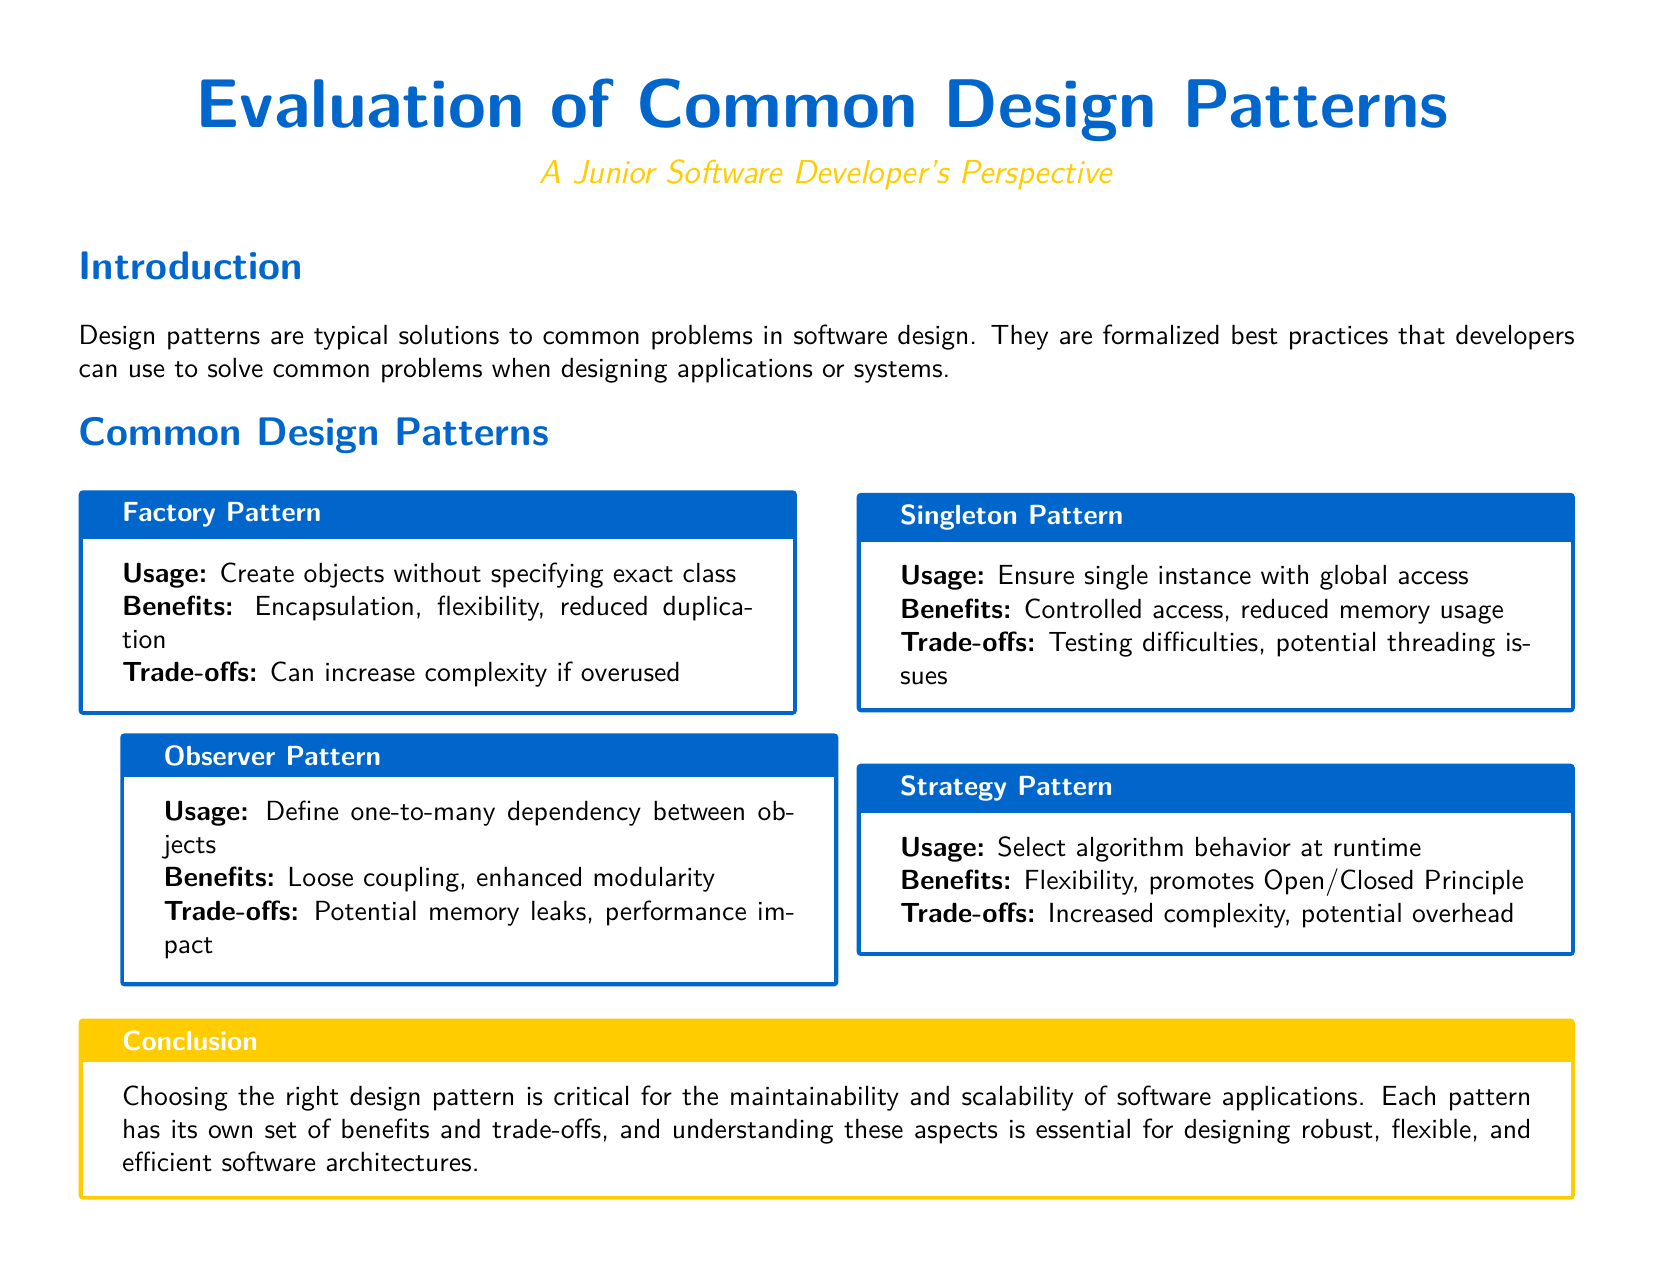What is the title of the document? The title is prominently displayed at the top of the document and is formatted in large font.
Answer: Evaluation of Common Design Patterns What color is the main text color used in the document? The main text color is indicated by a predefined color variable used throughout the document.
Answer: RGB(0,102,204) What is the usage of the Factory Pattern? The usage is described in the box dedicated to the Factory Pattern.
Answer: Create objects without specifying exact class What are the benefits of the Singleton Pattern? The benefits are listed in the corresponding box for the Singleton Pattern.
Answer: Controlled access, reduced memory usage What is one trade-off for the Observer Pattern? The trade-offs are mentioned under the box for the Observer Pattern.
Answer: Potential memory leaks What does the Strategy Pattern promote? This aspect is mentioned as a benefit of the Strategy Pattern.
Answer: Open/Closed Principle How many common design patterns are discussed in this document? This is determined by counting the distinct design patterns presented in the document.
Answer: Four What is the overall theme of the document? The overall theme is derived from the title and introductory section content.
Answer: Evaluation of Common Design Patterns What is emphasized as critical in the conclusion? The conclusion provides important insights regarding design patterns.
Answer: Choosing the right design pattern 